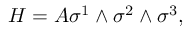Convert formula to latex. <formula><loc_0><loc_0><loc_500><loc_500>H = A \sigma ^ { 1 } \wedge \sigma ^ { 2 } \wedge \sigma ^ { 3 } ,</formula> 